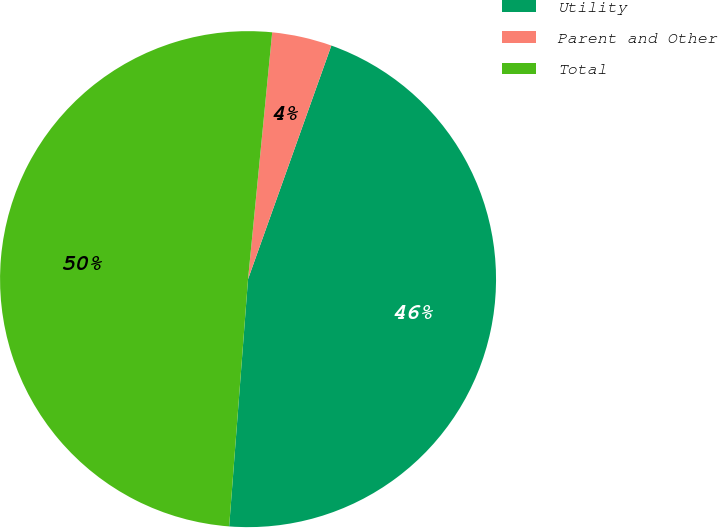<chart> <loc_0><loc_0><loc_500><loc_500><pie_chart><fcel>Utility<fcel>Parent and Other<fcel>Total<nl><fcel>45.76%<fcel>3.9%<fcel>50.34%<nl></chart> 